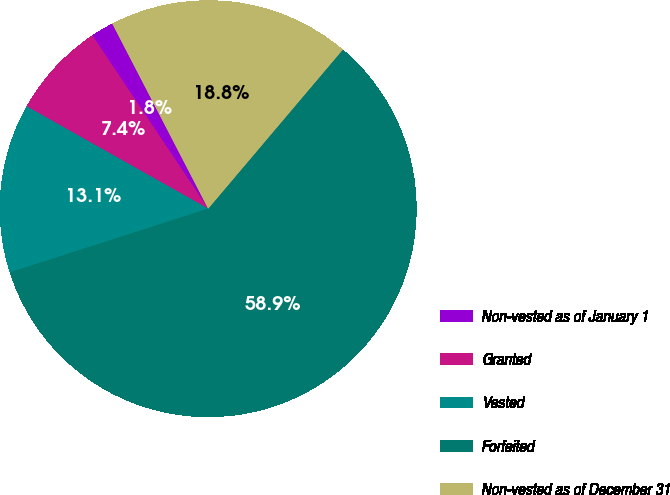Convert chart to OTSL. <chart><loc_0><loc_0><loc_500><loc_500><pie_chart><fcel>Non-vested as of January 1<fcel>Granted<fcel>Vested<fcel>Forfeited<fcel>Non-vested as of December 31<nl><fcel>1.77%<fcel>7.45%<fcel>13.12%<fcel>58.87%<fcel>18.79%<nl></chart> 